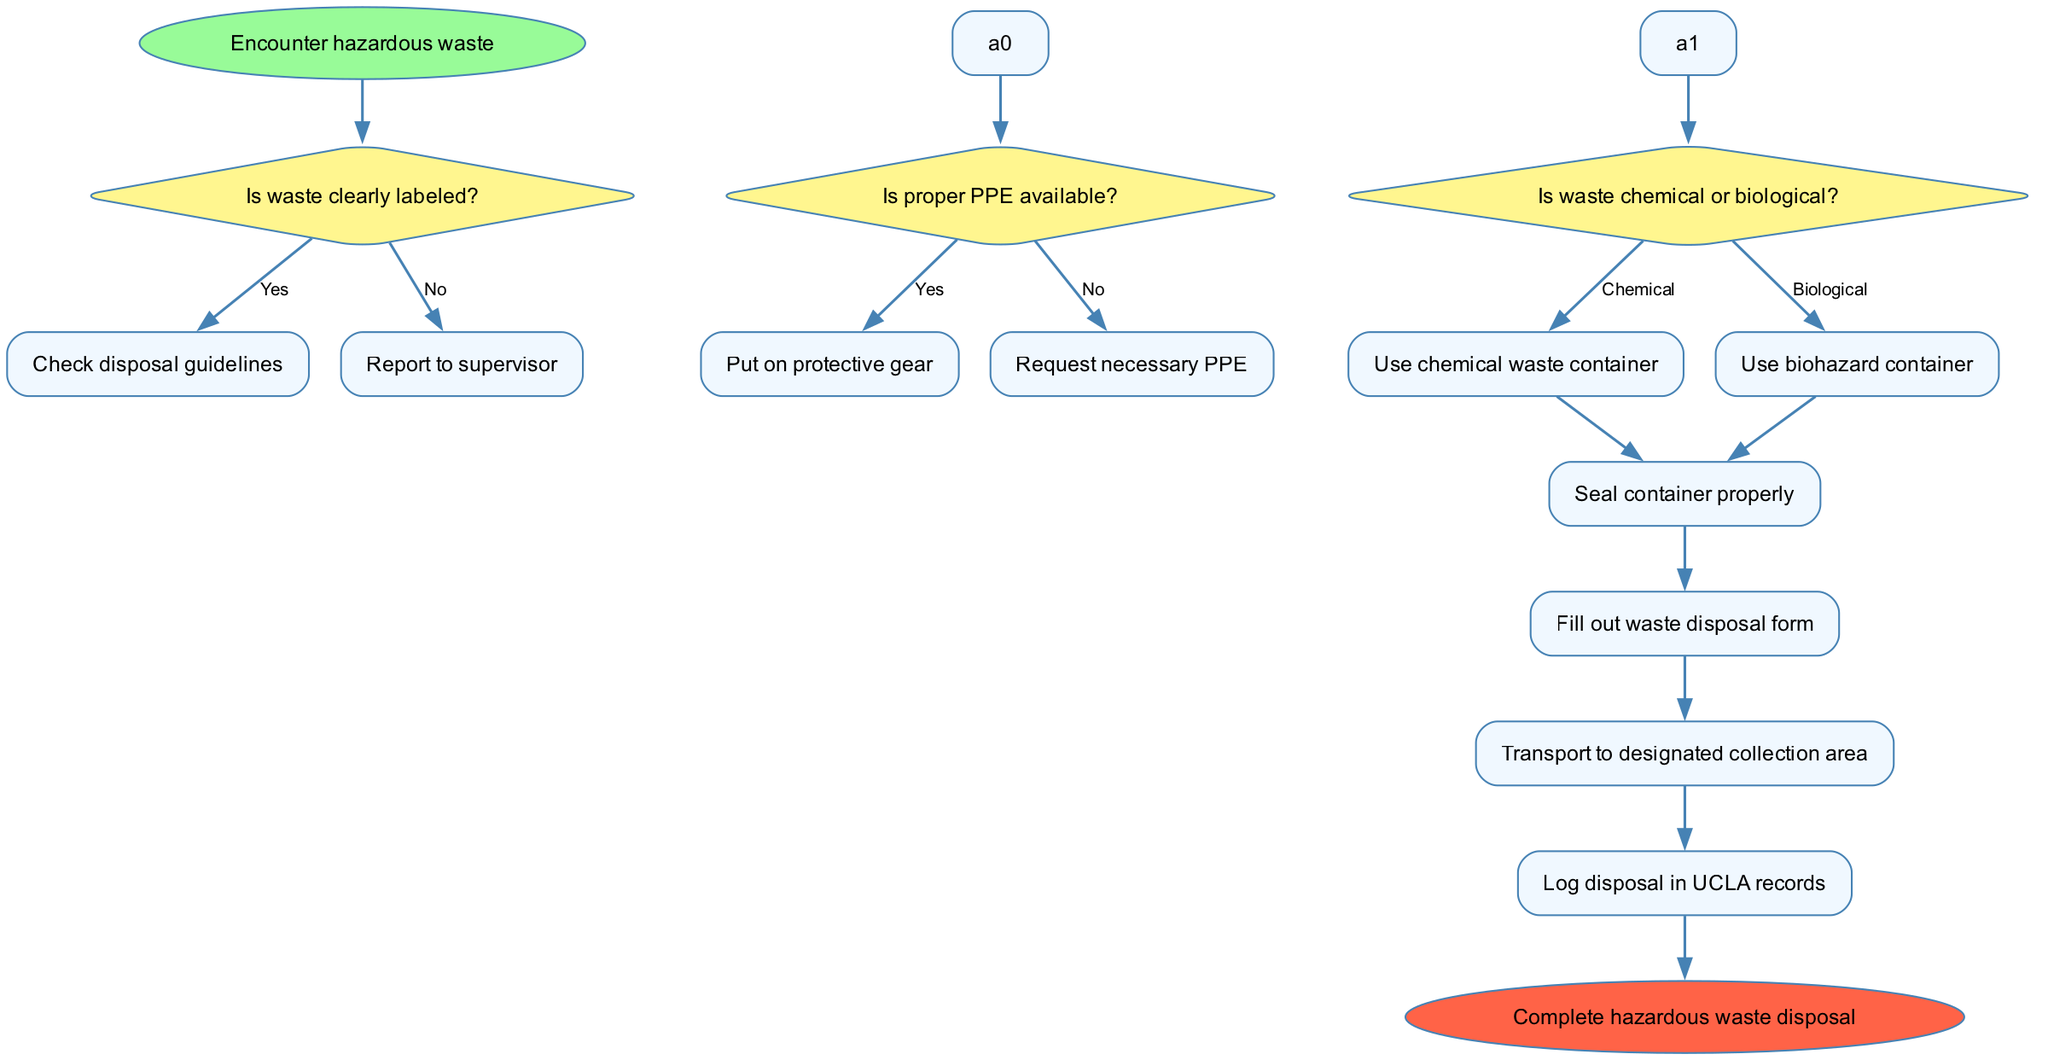What is the first action taken in the process? The flowchart indicates that "Seal container properly" is the first action after waste classification. It follows the decision-making based on whether the waste is labeled and whether PPE is available.
Answer: Seal container properly How many decisions are present in the diagram? The diagram shows a total of three decisions: "Is waste clearly labeled?", "Is proper PPE available?", and "Is waste chemical or biological?". Therefore, there are three decision nodes.
Answer: 3 What happens if the waste is not clearly labeled? If the waste is not clearly labeled, the flowchart directs to "Report to supervisor" from the decision node regarding labeling. This shows a straightforward next step when faced with unlabeled waste.
Answer: Report to supervisor If proper PPE is not available, what is the next step to take? In the scenario where proper PPE is not available, the flowchart indicates you should "Request necessary PPE". This response is directly linked to the decision about PPE availability.
Answer: Request necessary PPE What type of container should be used for biological waste? According to the flowchart, when the waste is classified as biological, the next step is to "Use biohazard container". This specifically indicates the type of container needed for biological hazardous waste.
Answer: Use biohazard container What are the total number of actions listed in the diagram? The diagram lists four distinct actions: "Seal container properly", "Fill out waste disposal form", "Transport to designated collection area", and "Log disposal in UCLA records". This amounts to a total of four action nodes.
Answer: 4 What does the flowchart indicate will happen at the end of the process? At the end of the process, the flowchart concludes with "Complete hazardous waste disposal", marking the final outcome or end point of the disposal process.
Answer: Complete hazardous waste disposal What is the color used for decision nodes in the diagram? The decision nodes are filled with a color defined as "#FFF68F," which indicates the visual styling uniformly applied to these types of nodes in the diagram.
Answer: Yellow If the waste is identified as chemical, what is the expected action? If the waste is classified as chemical, the flowchart directs to "Use chemical waste container" as the action taken after the classification decision is made.
Answer: Use chemical waste container 